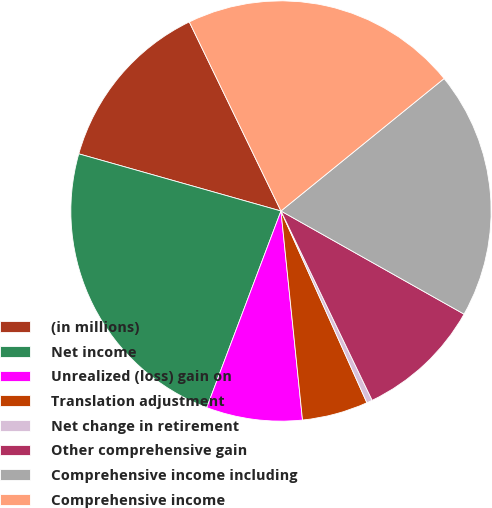Convert chart. <chart><loc_0><loc_0><loc_500><loc_500><pie_chart><fcel>(in millions)<fcel>Net income<fcel>Unrealized (loss) gain on<fcel>Translation adjustment<fcel>Net change in retirement<fcel>Other comprehensive gain<fcel>Comprehensive income including<fcel>Comprehensive income<nl><fcel>13.43%<fcel>23.64%<fcel>7.38%<fcel>5.07%<fcel>0.44%<fcel>9.69%<fcel>19.02%<fcel>21.33%<nl></chart> 